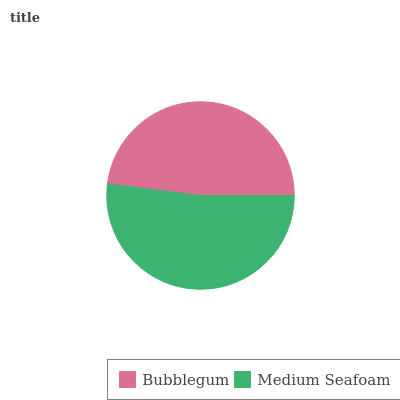Is Bubblegum the minimum?
Answer yes or no. Yes. Is Medium Seafoam the maximum?
Answer yes or no. Yes. Is Medium Seafoam the minimum?
Answer yes or no. No. Is Medium Seafoam greater than Bubblegum?
Answer yes or no. Yes. Is Bubblegum less than Medium Seafoam?
Answer yes or no. Yes. Is Bubblegum greater than Medium Seafoam?
Answer yes or no. No. Is Medium Seafoam less than Bubblegum?
Answer yes or no. No. Is Medium Seafoam the high median?
Answer yes or no. Yes. Is Bubblegum the low median?
Answer yes or no. Yes. Is Bubblegum the high median?
Answer yes or no. No. Is Medium Seafoam the low median?
Answer yes or no. No. 